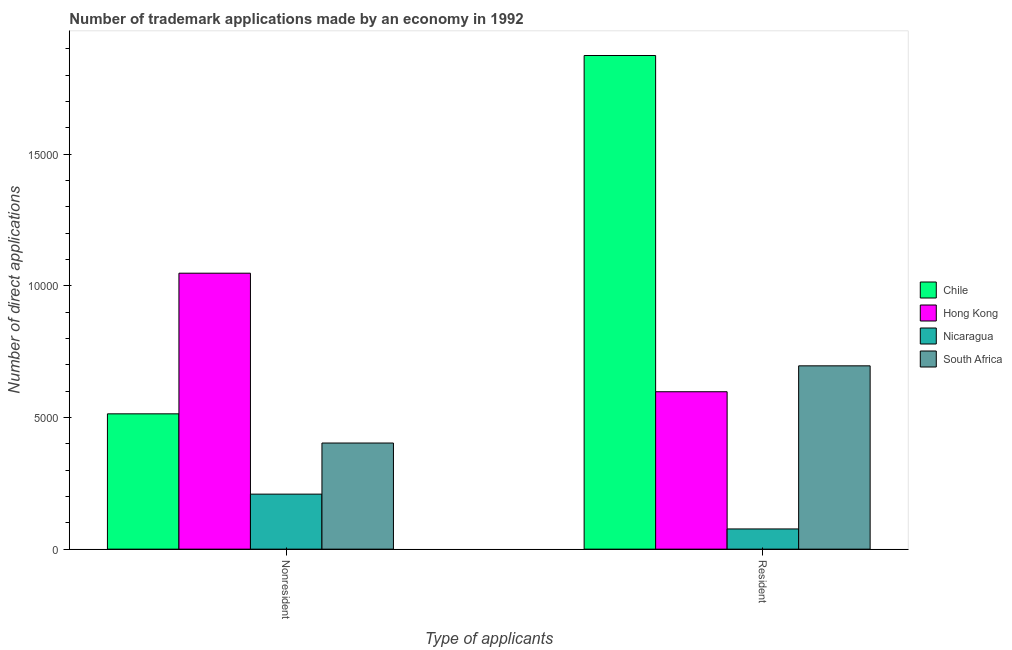Are the number of bars per tick equal to the number of legend labels?
Keep it short and to the point. Yes. How many bars are there on the 1st tick from the left?
Give a very brief answer. 4. How many bars are there on the 2nd tick from the right?
Your answer should be compact. 4. What is the label of the 1st group of bars from the left?
Your response must be concise. Nonresident. What is the number of trademark applications made by residents in Hong Kong?
Offer a very short reply. 5977. Across all countries, what is the maximum number of trademark applications made by non residents?
Ensure brevity in your answer.  1.05e+04. Across all countries, what is the minimum number of trademark applications made by non residents?
Offer a very short reply. 2089. In which country was the number of trademark applications made by non residents maximum?
Make the answer very short. Hong Kong. In which country was the number of trademark applications made by residents minimum?
Give a very brief answer. Nicaragua. What is the total number of trademark applications made by residents in the graph?
Make the answer very short. 3.24e+04. What is the difference between the number of trademark applications made by non residents in Hong Kong and that in South Africa?
Ensure brevity in your answer.  6449. What is the difference between the number of trademark applications made by residents in Nicaragua and the number of trademark applications made by non residents in South Africa?
Offer a terse response. -3263. What is the average number of trademark applications made by non residents per country?
Make the answer very short. 5434. What is the difference between the number of trademark applications made by residents and number of trademark applications made by non residents in Chile?
Provide a succinct answer. 1.36e+04. In how many countries, is the number of trademark applications made by residents greater than 8000 ?
Keep it short and to the point. 1. What is the ratio of the number of trademark applications made by non residents in Chile to that in South Africa?
Offer a very short reply. 1.27. Is the number of trademark applications made by residents in Nicaragua less than that in South Africa?
Offer a terse response. Yes. What does the 3rd bar from the right in Nonresident represents?
Ensure brevity in your answer.  Hong Kong. How many bars are there?
Your answer should be very brief. 8. What is the difference between two consecutive major ticks on the Y-axis?
Make the answer very short. 5000. Are the values on the major ticks of Y-axis written in scientific E-notation?
Make the answer very short. No. Does the graph contain any zero values?
Offer a terse response. No. Where does the legend appear in the graph?
Make the answer very short. Center right. How many legend labels are there?
Keep it short and to the point. 4. What is the title of the graph?
Make the answer very short. Number of trademark applications made by an economy in 1992. Does "Mali" appear as one of the legend labels in the graph?
Provide a short and direct response. No. What is the label or title of the X-axis?
Keep it short and to the point. Type of applicants. What is the label or title of the Y-axis?
Make the answer very short. Number of direct applications. What is the Number of direct applications in Chile in Nonresident?
Your answer should be very brief. 5138. What is the Number of direct applications in Hong Kong in Nonresident?
Provide a succinct answer. 1.05e+04. What is the Number of direct applications in Nicaragua in Nonresident?
Provide a short and direct response. 2089. What is the Number of direct applications in South Africa in Nonresident?
Keep it short and to the point. 4030. What is the Number of direct applications of Chile in Resident?
Your answer should be compact. 1.87e+04. What is the Number of direct applications in Hong Kong in Resident?
Offer a very short reply. 5977. What is the Number of direct applications in Nicaragua in Resident?
Give a very brief answer. 767. What is the Number of direct applications of South Africa in Resident?
Make the answer very short. 6961. Across all Type of applicants, what is the maximum Number of direct applications of Chile?
Your answer should be compact. 1.87e+04. Across all Type of applicants, what is the maximum Number of direct applications in Hong Kong?
Give a very brief answer. 1.05e+04. Across all Type of applicants, what is the maximum Number of direct applications in Nicaragua?
Keep it short and to the point. 2089. Across all Type of applicants, what is the maximum Number of direct applications in South Africa?
Make the answer very short. 6961. Across all Type of applicants, what is the minimum Number of direct applications of Chile?
Provide a short and direct response. 5138. Across all Type of applicants, what is the minimum Number of direct applications of Hong Kong?
Offer a very short reply. 5977. Across all Type of applicants, what is the minimum Number of direct applications of Nicaragua?
Ensure brevity in your answer.  767. Across all Type of applicants, what is the minimum Number of direct applications in South Africa?
Keep it short and to the point. 4030. What is the total Number of direct applications of Chile in the graph?
Your response must be concise. 2.39e+04. What is the total Number of direct applications in Hong Kong in the graph?
Your answer should be very brief. 1.65e+04. What is the total Number of direct applications in Nicaragua in the graph?
Your response must be concise. 2856. What is the total Number of direct applications of South Africa in the graph?
Your response must be concise. 1.10e+04. What is the difference between the Number of direct applications of Chile in Nonresident and that in Resident?
Keep it short and to the point. -1.36e+04. What is the difference between the Number of direct applications of Hong Kong in Nonresident and that in Resident?
Give a very brief answer. 4502. What is the difference between the Number of direct applications of Nicaragua in Nonresident and that in Resident?
Provide a short and direct response. 1322. What is the difference between the Number of direct applications in South Africa in Nonresident and that in Resident?
Ensure brevity in your answer.  -2931. What is the difference between the Number of direct applications in Chile in Nonresident and the Number of direct applications in Hong Kong in Resident?
Offer a terse response. -839. What is the difference between the Number of direct applications of Chile in Nonresident and the Number of direct applications of Nicaragua in Resident?
Ensure brevity in your answer.  4371. What is the difference between the Number of direct applications in Chile in Nonresident and the Number of direct applications in South Africa in Resident?
Provide a succinct answer. -1823. What is the difference between the Number of direct applications in Hong Kong in Nonresident and the Number of direct applications in Nicaragua in Resident?
Provide a short and direct response. 9712. What is the difference between the Number of direct applications of Hong Kong in Nonresident and the Number of direct applications of South Africa in Resident?
Ensure brevity in your answer.  3518. What is the difference between the Number of direct applications of Nicaragua in Nonresident and the Number of direct applications of South Africa in Resident?
Offer a very short reply. -4872. What is the average Number of direct applications in Chile per Type of applicants?
Provide a succinct answer. 1.19e+04. What is the average Number of direct applications in Hong Kong per Type of applicants?
Ensure brevity in your answer.  8228. What is the average Number of direct applications in Nicaragua per Type of applicants?
Your answer should be very brief. 1428. What is the average Number of direct applications of South Africa per Type of applicants?
Keep it short and to the point. 5495.5. What is the difference between the Number of direct applications in Chile and Number of direct applications in Hong Kong in Nonresident?
Your answer should be compact. -5341. What is the difference between the Number of direct applications in Chile and Number of direct applications in Nicaragua in Nonresident?
Your answer should be compact. 3049. What is the difference between the Number of direct applications of Chile and Number of direct applications of South Africa in Nonresident?
Keep it short and to the point. 1108. What is the difference between the Number of direct applications in Hong Kong and Number of direct applications in Nicaragua in Nonresident?
Your answer should be very brief. 8390. What is the difference between the Number of direct applications in Hong Kong and Number of direct applications in South Africa in Nonresident?
Provide a short and direct response. 6449. What is the difference between the Number of direct applications of Nicaragua and Number of direct applications of South Africa in Nonresident?
Provide a short and direct response. -1941. What is the difference between the Number of direct applications in Chile and Number of direct applications in Hong Kong in Resident?
Your answer should be compact. 1.28e+04. What is the difference between the Number of direct applications of Chile and Number of direct applications of Nicaragua in Resident?
Make the answer very short. 1.80e+04. What is the difference between the Number of direct applications in Chile and Number of direct applications in South Africa in Resident?
Your response must be concise. 1.18e+04. What is the difference between the Number of direct applications of Hong Kong and Number of direct applications of Nicaragua in Resident?
Give a very brief answer. 5210. What is the difference between the Number of direct applications in Hong Kong and Number of direct applications in South Africa in Resident?
Your answer should be very brief. -984. What is the difference between the Number of direct applications of Nicaragua and Number of direct applications of South Africa in Resident?
Make the answer very short. -6194. What is the ratio of the Number of direct applications of Chile in Nonresident to that in Resident?
Your answer should be very brief. 0.27. What is the ratio of the Number of direct applications in Hong Kong in Nonresident to that in Resident?
Give a very brief answer. 1.75. What is the ratio of the Number of direct applications in Nicaragua in Nonresident to that in Resident?
Provide a short and direct response. 2.72. What is the ratio of the Number of direct applications in South Africa in Nonresident to that in Resident?
Offer a very short reply. 0.58. What is the difference between the highest and the second highest Number of direct applications of Chile?
Your answer should be very brief. 1.36e+04. What is the difference between the highest and the second highest Number of direct applications of Hong Kong?
Provide a short and direct response. 4502. What is the difference between the highest and the second highest Number of direct applications in Nicaragua?
Keep it short and to the point. 1322. What is the difference between the highest and the second highest Number of direct applications of South Africa?
Offer a terse response. 2931. What is the difference between the highest and the lowest Number of direct applications in Chile?
Make the answer very short. 1.36e+04. What is the difference between the highest and the lowest Number of direct applications in Hong Kong?
Provide a succinct answer. 4502. What is the difference between the highest and the lowest Number of direct applications in Nicaragua?
Ensure brevity in your answer.  1322. What is the difference between the highest and the lowest Number of direct applications in South Africa?
Your answer should be compact. 2931. 